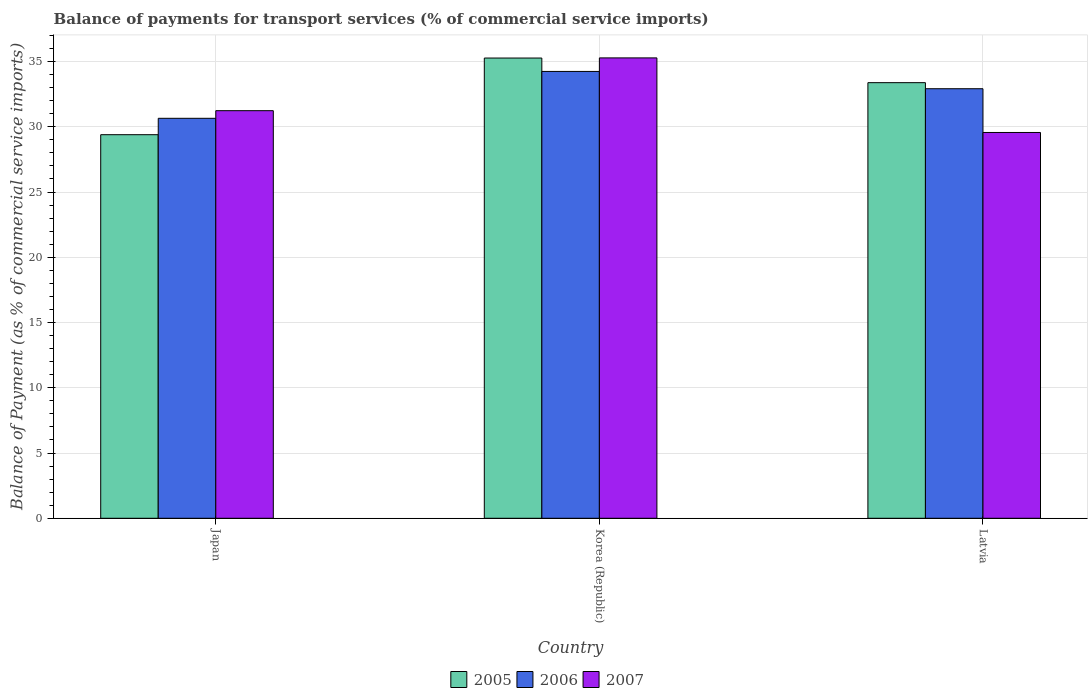In how many cases, is the number of bars for a given country not equal to the number of legend labels?
Offer a terse response. 0. What is the balance of payments for transport services in 2005 in Korea (Republic)?
Offer a very short reply. 35.27. Across all countries, what is the maximum balance of payments for transport services in 2007?
Make the answer very short. 35.28. Across all countries, what is the minimum balance of payments for transport services in 2005?
Give a very brief answer. 29.4. In which country was the balance of payments for transport services in 2007 minimum?
Your answer should be very brief. Latvia. What is the total balance of payments for transport services in 2005 in the graph?
Offer a terse response. 98.05. What is the difference between the balance of payments for transport services in 2006 in Korea (Republic) and that in Latvia?
Your answer should be compact. 1.33. What is the difference between the balance of payments for transport services in 2005 in Latvia and the balance of payments for transport services in 2006 in Korea (Republic)?
Provide a short and direct response. -0.86. What is the average balance of payments for transport services in 2006 per country?
Make the answer very short. 32.6. What is the difference between the balance of payments for transport services of/in 2007 and balance of payments for transport services of/in 2005 in Korea (Republic)?
Give a very brief answer. 0.01. In how many countries, is the balance of payments for transport services in 2005 greater than 15 %?
Offer a terse response. 3. What is the ratio of the balance of payments for transport services in 2007 in Japan to that in Latvia?
Your answer should be compact. 1.06. Is the balance of payments for transport services in 2007 in Japan less than that in Latvia?
Offer a very short reply. No. Is the difference between the balance of payments for transport services in 2007 in Japan and Latvia greater than the difference between the balance of payments for transport services in 2005 in Japan and Latvia?
Your answer should be compact. Yes. What is the difference between the highest and the second highest balance of payments for transport services in 2007?
Provide a short and direct response. 5.72. What is the difference between the highest and the lowest balance of payments for transport services in 2007?
Keep it short and to the point. 5.72. In how many countries, is the balance of payments for transport services in 2005 greater than the average balance of payments for transport services in 2005 taken over all countries?
Make the answer very short. 2. Is the sum of the balance of payments for transport services in 2005 in Korea (Republic) and Latvia greater than the maximum balance of payments for transport services in 2006 across all countries?
Your answer should be very brief. Yes. What does the 3rd bar from the left in Japan represents?
Provide a succinct answer. 2007. What does the 1st bar from the right in Korea (Republic) represents?
Make the answer very short. 2007. Is it the case that in every country, the sum of the balance of payments for transport services in 2007 and balance of payments for transport services in 2005 is greater than the balance of payments for transport services in 2006?
Your response must be concise. Yes. How many bars are there?
Provide a short and direct response. 9. Are all the bars in the graph horizontal?
Offer a very short reply. No. How many countries are there in the graph?
Your answer should be very brief. 3. Are the values on the major ticks of Y-axis written in scientific E-notation?
Your response must be concise. No. Does the graph contain grids?
Offer a very short reply. Yes. Where does the legend appear in the graph?
Offer a terse response. Bottom center. How many legend labels are there?
Offer a very short reply. 3. How are the legend labels stacked?
Give a very brief answer. Horizontal. What is the title of the graph?
Your answer should be compact. Balance of payments for transport services (% of commercial service imports). What is the label or title of the Y-axis?
Ensure brevity in your answer.  Balance of Payment (as % of commercial service imports). What is the Balance of Payment (as % of commercial service imports) in 2005 in Japan?
Offer a very short reply. 29.4. What is the Balance of Payment (as % of commercial service imports) of 2006 in Japan?
Your answer should be very brief. 30.65. What is the Balance of Payment (as % of commercial service imports) in 2007 in Japan?
Your response must be concise. 31.23. What is the Balance of Payment (as % of commercial service imports) in 2005 in Korea (Republic)?
Keep it short and to the point. 35.27. What is the Balance of Payment (as % of commercial service imports) in 2006 in Korea (Republic)?
Provide a succinct answer. 34.24. What is the Balance of Payment (as % of commercial service imports) of 2007 in Korea (Republic)?
Give a very brief answer. 35.28. What is the Balance of Payment (as % of commercial service imports) in 2005 in Latvia?
Offer a terse response. 33.38. What is the Balance of Payment (as % of commercial service imports) in 2006 in Latvia?
Your answer should be very brief. 32.92. What is the Balance of Payment (as % of commercial service imports) of 2007 in Latvia?
Offer a terse response. 29.56. Across all countries, what is the maximum Balance of Payment (as % of commercial service imports) of 2005?
Ensure brevity in your answer.  35.27. Across all countries, what is the maximum Balance of Payment (as % of commercial service imports) of 2006?
Keep it short and to the point. 34.24. Across all countries, what is the maximum Balance of Payment (as % of commercial service imports) in 2007?
Give a very brief answer. 35.28. Across all countries, what is the minimum Balance of Payment (as % of commercial service imports) of 2005?
Provide a short and direct response. 29.4. Across all countries, what is the minimum Balance of Payment (as % of commercial service imports) of 2006?
Your answer should be very brief. 30.65. Across all countries, what is the minimum Balance of Payment (as % of commercial service imports) in 2007?
Give a very brief answer. 29.56. What is the total Balance of Payment (as % of commercial service imports) of 2005 in the graph?
Your answer should be compact. 98.05. What is the total Balance of Payment (as % of commercial service imports) in 2006 in the graph?
Make the answer very short. 97.81. What is the total Balance of Payment (as % of commercial service imports) in 2007 in the graph?
Your response must be concise. 96.08. What is the difference between the Balance of Payment (as % of commercial service imports) of 2005 in Japan and that in Korea (Republic)?
Offer a terse response. -5.87. What is the difference between the Balance of Payment (as % of commercial service imports) in 2006 in Japan and that in Korea (Republic)?
Your answer should be very brief. -3.59. What is the difference between the Balance of Payment (as % of commercial service imports) in 2007 in Japan and that in Korea (Republic)?
Keep it short and to the point. -4.05. What is the difference between the Balance of Payment (as % of commercial service imports) of 2005 in Japan and that in Latvia?
Provide a succinct answer. -3.99. What is the difference between the Balance of Payment (as % of commercial service imports) in 2006 in Japan and that in Latvia?
Provide a succinct answer. -2.27. What is the difference between the Balance of Payment (as % of commercial service imports) in 2007 in Japan and that in Latvia?
Ensure brevity in your answer.  1.67. What is the difference between the Balance of Payment (as % of commercial service imports) of 2005 in Korea (Republic) and that in Latvia?
Make the answer very short. 1.89. What is the difference between the Balance of Payment (as % of commercial service imports) of 2006 in Korea (Republic) and that in Latvia?
Ensure brevity in your answer.  1.33. What is the difference between the Balance of Payment (as % of commercial service imports) in 2007 in Korea (Republic) and that in Latvia?
Keep it short and to the point. 5.72. What is the difference between the Balance of Payment (as % of commercial service imports) of 2005 in Japan and the Balance of Payment (as % of commercial service imports) of 2006 in Korea (Republic)?
Your answer should be very brief. -4.85. What is the difference between the Balance of Payment (as % of commercial service imports) in 2005 in Japan and the Balance of Payment (as % of commercial service imports) in 2007 in Korea (Republic)?
Offer a terse response. -5.88. What is the difference between the Balance of Payment (as % of commercial service imports) in 2006 in Japan and the Balance of Payment (as % of commercial service imports) in 2007 in Korea (Republic)?
Make the answer very short. -4.63. What is the difference between the Balance of Payment (as % of commercial service imports) of 2005 in Japan and the Balance of Payment (as % of commercial service imports) of 2006 in Latvia?
Offer a terse response. -3.52. What is the difference between the Balance of Payment (as % of commercial service imports) of 2005 in Japan and the Balance of Payment (as % of commercial service imports) of 2007 in Latvia?
Your answer should be very brief. -0.17. What is the difference between the Balance of Payment (as % of commercial service imports) of 2006 in Japan and the Balance of Payment (as % of commercial service imports) of 2007 in Latvia?
Provide a short and direct response. 1.09. What is the difference between the Balance of Payment (as % of commercial service imports) in 2005 in Korea (Republic) and the Balance of Payment (as % of commercial service imports) in 2006 in Latvia?
Offer a very short reply. 2.35. What is the difference between the Balance of Payment (as % of commercial service imports) of 2005 in Korea (Republic) and the Balance of Payment (as % of commercial service imports) of 2007 in Latvia?
Offer a terse response. 5.71. What is the difference between the Balance of Payment (as % of commercial service imports) of 2006 in Korea (Republic) and the Balance of Payment (as % of commercial service imports) of 2007 in Latvia?
Your response must be concise. 4.68. What is the average Balance of Payment (as % of commercial service imports) in 2005 per country?
Provide a short and direct response. 32.68. What is the average Balance of Payment (as % of commercial service imports) in 2006 per country?
Make the answer very short. 32.6. What is the average Balance of Payment (as % of commercial service imports) in 2007 per country?
Your answer should be very brief. 32.03. What is the difference between the Balance of Payment (as % of commercial service imports) in 2005 and Balance of Payment (as % of commercial service imports) in 2006 in Japan?
Your answer should be very brief. -1.26. What is the difference between the Balance of Payment (as % of commercial service imports) in 2005 and Balance of Payment (as % of commercial service imports) in 2007 in Japan?
Provide a succinct answer. -1.84. What is the difference between the Balance of Payment (as % of commercial service imports) of 2006 and Balance of Payment (as % of commercial service imports) of 2007 in Japan?
Your answer should be very brief. -0.58. What is the difference between the Balance of Payment (as % of commercial service imports) in 2005 and Balance of Payment (as % of commercial service imports) in 2006 in Korea (Republic)?
Your answer should be compact. 1.03. What is the difference between the Balance of Payment (as % of commercial service imports) of 2005 and Balance of Payment (as % of commercial service imports) of 2007 in Korea (Republic)?
Offer a very short reply. -0.01. What is the difference between the Balance of Payment (as % of commercial service imports) of 2006 and Balance of Payment (as % of commercial service imports) of 2007 in Korea (Republic)?
Make the answer very short. -1.04. What is the difference between the Balance of Payment (as % of commercial service imports) of 2005 and Balance of Payment (as % of commercial service imports) of 2006 in Latvia?
Make the answer very short. 0.46. What is the difference between the Balance of Payment (as % of commercial service imports) in 2005 and Balance of Payment (as % of commercial service imports) in 2007 in Latvia?
Keep it short and to the point. 3.82. What is the difference between the Balance of Payment (as % of commercial service imports) of 2006 and Balance of Payment (as % of commercial service imports) of 2007 in Latvia?
Ensure brevity in your answer.  3.35. What is the ratio of the Balance of Payment (as % of commercial service imports) in 2005 in Japan to that in Korea (Republic)?
Your answer should be very brief. 0.83. What is the ratio of the Balance of Payment (as % of commercial service imports) in 2006 in Japan to that in Korea (Republic)?
Make the answer very short. 0.9. What is the ratio of the Balance of Payment (as % of commercial service imports) in 2007 in Japan to that in Korea (Republic)?
Your answer should be very brief. 0.89. What is the ratio of the Balance of Payment (as % of commercial service imports) of 2005 in Japan to that in Latvia?
Give a very brief answer. 0.88. What is the ratio of the Balance of Payment (as % of commercial service imports) of 2006 in Japan to that in Latvia?
Your answer should be very brief. 0.93. What is the ratio of the Balance of Payment (as % of commercial service imports) in 2007 in Japan to that in Latvia?
Your answer should be compact. 1.06. What is the ratio of the Balance of Payment (as % of commercial service imports) of 2005 in Korea (Republic) to that in Latvia?
Your answer should be very brief. 1.06. What is the ratio of the Balance of Payment (as % of commercial service imports) in 2006 in Korea (Republic) to that in Latvia?
Your response must be concise. 1.04. What is the ratio of the Balance of Payment (as % of commercial service imports) in 2007 in Korea (Republic) to that in Latvia?
Keep it short and to the point. 1.19. What is the difference between the highest and the second highest Balance of Payment (as % of commercial service imports) in 2005?
Offer a terse response. 1.89. What is the difference between the highest and the second highest Balance of Payment (as % of commercial service imports) of 2006?
Provide a short and direct response. 1.33. What is the difference between the highest and the second highest Balance of Payment (as % of commercial service imports) in 2007?
Offer a terse response. 4.05. What is the difference between the highest and the lowest Balance of Payment (as % of commercial service imports) of 2005?
Your answer should be compact. 5.87. What is the difference between the highest and the lowest Balance of Payment (as % of commercial service imports) in 2006?
Provide a succinct answer. 3.59. What is the difference between the highest and the lowest Balance of Payment (as % of commercial service imports) of 2007?
Provide a succinct answer. 5.72. 